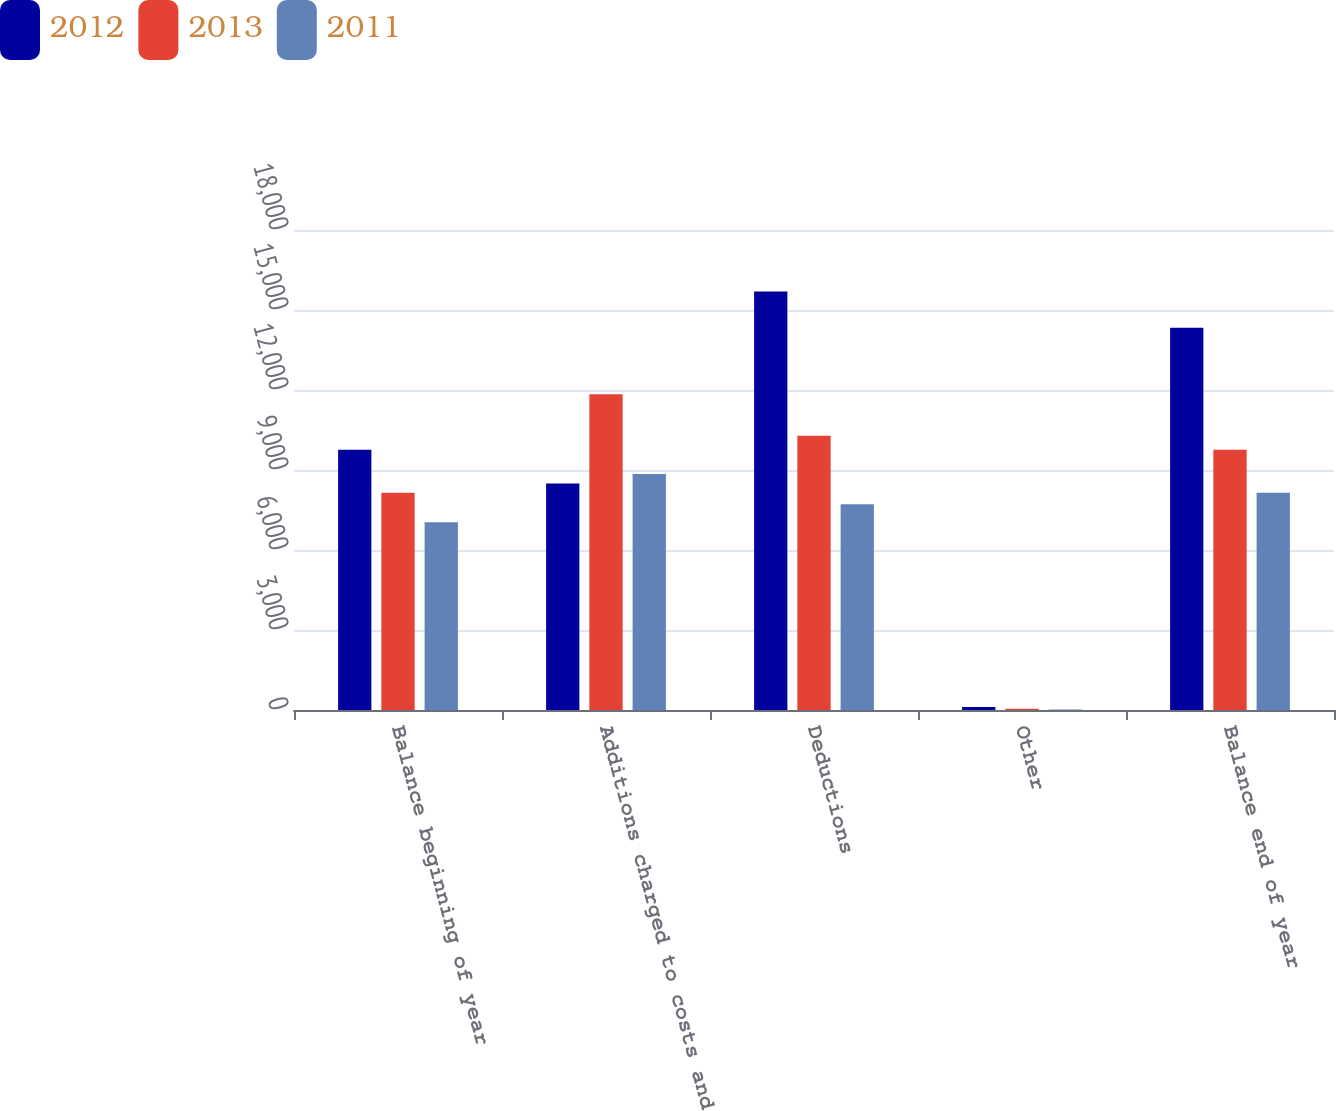Convert chart. <chart><loc_0><loc_0><loc_500><loc_500><stacked_bar_chart><ecel><fcel>Balance beginning of year<fcel>Additions charged to costs and<fcel>Deductions<fcel>Other<fcel>Balance end of year<nl><fcel>2012<fcel>9755<fcel>8496.5<fcel>15697<fcel>109<fcel>14336<nl><fcel>2013<fcel>8147<fcel>11845<fcel>10287<fcel>50<fcel>9755<nl><fcel>2011<fcel>7038<fcel>8846<fcel>7716<fcel>21<fcel>8147<nl></chart> 